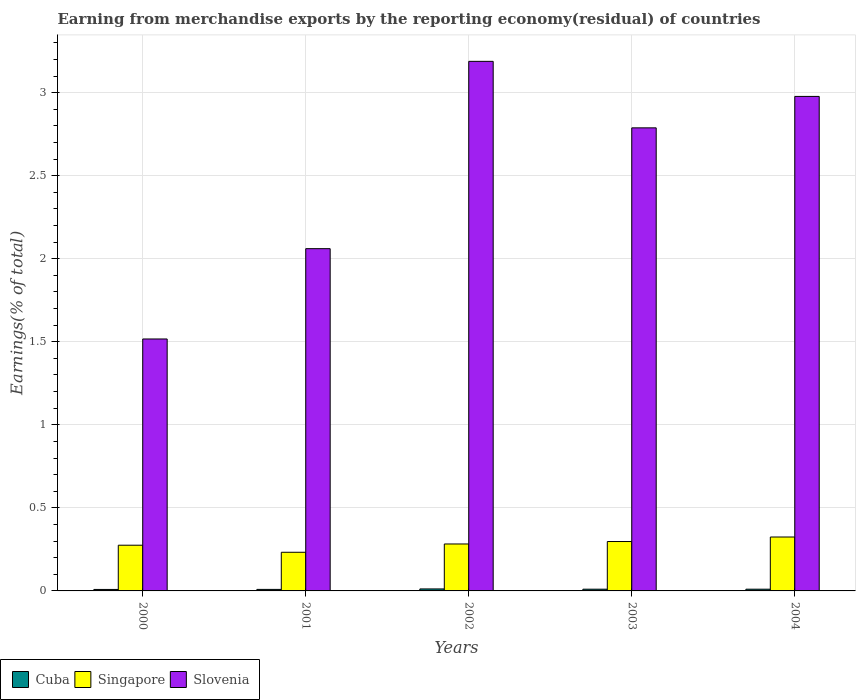How many different coloured bars are there?
Offer a very short reply. 3. How many groups of bars are there?
Give a very brief answer. 5. How many bars are there on the 5th tick from the left?
Your answer should be very brief. 3. What is the label of the 2nd group of bars from the left?
Provide a short and direct response. 2001. In how many cases, is the number of bars for a given year not equal to the number of legend labels?
Your answer should be compact. 0. What is the percentage of amount earned from merchandise exports in Singapore in 2004?
Give a very brief answer. 0.32. Across all years, what is the maximum percentage of amount earned from merchandise exports in Singapore?
Your answer should be very brief. 0.32. Across all years, what is the minimum percentage of amount earned from merchandise exports in Cuba?
Offer a very short reply. 0.01. In which year was the percentage of amount earned from merchandise exports in Cuba maximum?
Give a very brief answer. 2002. In which year was the percentage of amount earned from merchandise exports in Slovenia minimum?
Make the answer very short. 2000. What is the total percentage of amount earned from merchandise exports in Slovenia in the graph?
Ensure brevity in your answer.  12.53. What is the difference between the percentage of amount earned from merchandise exports in Singapore in 2002 and that in 2003?
Your response must be concise. -0.01. What is the difference between the percentage of amount earned from merchandise exports in Cuba in 2003 and the percentage of amount earned from merchandise exports in Singapore in 2002?
Your answer should be compact. -0.27. What is the average percentage of amount earned from merchandise exports in Singapore per year?
Provide a short and direct response. 0.28. In the year 2003, what is the difference between the percentage of amount earned from merchandise exports in Slovenia and percentage of amount earned from merchandise exports in Cuba?
Your answer should be compact. 2.78. In how many years, is the percentage of amount earned from merchandise exports in Slovenia greater than 3.2 %?
Your answer should be very brief. 0. What is the ratio of the percentage of amount earned from merchandise exports in Cuba in 2002 to that in 2004?
Your response must be concise. 1.16. Is the percentage of amount earned from merchandise exports in Cuba in 2001 less than that in 2002?
Provide a succinct answer. Yes. What is the difference between the highest and the second highest percentage of amount earned from merchandise exports in Singapore?
Your answer should be very brief. 0.03. What is the difference between the highest and the lowest percentage of amount earned from merchandise exports in Singapore?
Make the answer very short. 0.09. In how many years, is the percentage of amount earned from merchandise exports in Slovenia greater than the average percentage of amount earned from merchandise exports in Slovenia taken over all years?
Offer a terse response. 3. Is the sum of the percentage of amount earned from merchandise exports in Slovenia in 2002 and 2003 greater than the maximum percentage of amount earned from merchandise exports in Cuba across all years?
Ensure brevity in your answer.  Yes. What does the 1st bar from the left in 2004 represents?
Offer a terse response. Cuba. What does the 3rd bar from the right in 2002 represents?
Offer a very short reply. Cuba. How many bars are there?
Offer a terse response. 15. Are all the bars in the graph horizontal?
Offer a very short reply. No. How many years are there in the graph?
Offer a terse response. 5. Are the values on the major ticks of Y-axis written in scientific E-notation?
Give a very brief answer. No. Does the graph contain any zero values?
Offer a terse response. No. How many legend labels are there?
Your response must be concise. 3. How are the legend labels stacked?
Your answer should be very brief. Horizontal. What is the title of the graph?
Your response must be concise. Earning from merchandise exports by the reporting economy(residual) of countries. Does "Belize" appear as one of the legend labels in the graph?
Provide a short and direct response. No. What is the label or title of the Y-axis?
Offer a terse response. Earnings(% of total). What is the Earnings(% of total) in Cuba in 2000?
Keep it short and to the point. 0.01. What is the Earnings(% of total) in Singapore in 2000?
Provide a succinct answer. 0.28. What is the Earnings(% of total) in Slovenia in 2000?
Offer a terse response. 1.52. What is the Earnings(% of total) in Cuba in 2001?
Give a very brief answer. 0.01. What is the Earnings(% of total) in Singapore in 2001?
Your response must be concise. 0.23. What is the Earnings(% of total) in Slovenia in 2001?
Offer a terse response. 2.06. What is the Earnings(% of total) in Cuba in 2002?
Your response must be concise. 0.01. What is the Earnings(% of total) of Singapore in 2002?
Offer a terse response. 0.28. What is the Earnings(% of total) of Slovenia in 2002?
Your answer should be very brief. 3.19. What is the Earnings(% of total) of Cuba in 2003?
Provide a succinct answer. 0.01. What is the Earnings(% of total) in Singapore in 2003?
Ensure brevity in your answer.  0.3. What is the Earnings(% of total) in Slovenia in 2003?
Your response must be concise. 2.79. What is the Earnings(% of total) in Cuba in 2004?
Your answer should be very brief. 0.01. What is the Earnings(% of total) of Singapore in 2004?
Give a very brief answer. 0.32. What is the Earnings(% of total) in Slovenia in 2004?
Ensure brevity in your answer.  2.98. Across all years, what is the maximum Earnings(% of total) of Cuba?
Give a very brief answer. 0.01. Across all years, what is the maximum Earnings(% of total) in Singapore?
Give a very brief answer. 0.32. Across all years, what is the maximum Earnings(% of total) in Slovenia?
Make the answer very short. 3.19. Across all years, what is the minimum Earnings(% of total) in Cuba?
Make the answer very short. 0.01. Across all years, what is the minimum Earnings(% of total) in Singapore?
Provide a short and direct response. 0.23. Across all years, what is the minimum Earnings(% of total) in Slovenia?
Give a very brief answer. 1.52. What is the total Earnings(% of total) of Cuba in the graph?
Your answer should be very brief. 0.05. What is the total Earnings(% of total) of Singapore in the graph?
Offer a very short reply. 1.41. What is the total Earnings(% of total) of Slovenia in the graph?
Your answer should be very brief. 12.53. What is the difference between the Earnings(% of total) in Cuba in 2000 and that in 2001?
Provide a short and direct response. -0. What is the difference between the Earnings(% of total) of Singapore in 2000 and that in 2001?
Keep it short and to the point. 0.04. What is the difference between the Earnings(% of total) of Slovenia in 2000 and that in 2001?
Make the answer very short. -0.54. What is the difference between the Earnings(% of total) in Cuba in 2000 and that in 2002?
Your answer should be compact. -0. What is the difference between the Earnings(% of total) of Singapore in 2000 and that in 2002?
Provide a short and direct response. -0.01. What is the difference between the Earnings(% of total) in Slovenia in 2000 and that in 2002?
Your answer should be compact. -1.67. What is the difference between the Earnings(% of total) in Cuba in 2000 and that in 2003?
Ensure brevity in your answer.  -0. What is the difference between the Earnings(% of total) of Singapore in 2000 and that in 2003?
Offer a terse response. -0.02. What is the difference between the Earnings(% of total) in Slovenia in 2000 and that in 2003?
Your answer should be very brief. -1.27. What is the difference between the Earnings(% of total) of Cuba in 2000 and that in 2004?
Give a very brief answer. -0. What is the difference between the Earnings(% of total) of Singapore in 2000 and that in 2004?
Your answer should be compact. -0.05. What is the difference between the Earnings(% of total) in Slovenia in 2000 and that in 2004?
Your response must be concise. -1.46. What is the difference between the Earnings(% of total) in Cuba in 2001 and that in 2002?
Give a very brief answer. -0. What is the difference between the Earnings(% of total) in Slovenia in 2001 and that in 2002?
Offer a very short reply. -1.13. What is the difference between the Earnings(% of total) of Cuba in 2001 and that in 2003?
Offer a terse response. -0. What is the difference between the Earnings(% of total) of Singapore in 2001 and that in 2003?
Keep it short and to the point. -0.06. What is the difference between the Earnings(% of total) in Slovenia in 2001 and that in 2003?
Make the answer very short. -0.73. What is the difference between the Earnings(% of total) in Cuba in 2001 and that in 2004?
Give a very brief answer. -0. What is the difference between the Earnings(% of total) in Singapore in 2001 and that in 2004?
Offer a very short reply. -0.09. What is the difference between the Earnings(% of total) of Slovenia in 2001 and that in 2004?
Make the answer very short. -0.92. What is the difference between the Earnings(% of total) in Cuba in 2002 and that in 2003?
Your answer should be very brief. 0. What is the difference between the Earnings(% of total) in Singapore in 2002 and that in 2003?
Ensure brevity in your answer.  -0.01. What is the difference between the Earnings(% of total) in Slovenia in 2002 and that in 2003?
Provide a short and direct response. 0.4. What is the difference between the Earnings(% of total) in Cuba in 2002 and that in 2004?
Provide a succinct answer. 0. What is the difference between the Earnings(% of total) of Singapore in 2002 and that in 2004?
Make the answer very short. -0.04. What is the difference between the Earnings(% of total) in Slovenia in 2002 and that in 2004?
Your response must be concise. 0.21. What is the difference between the Earnings(% of total) of Singapore in 2003 and that in 2004?
Make the answer very short. -0.03. What is the difference between the Earnings(% of total) in Slovenia in 2003 and that in 2004?
Your answer should be compact. -0.19. What is the difference between the Earnings(% of total) in Cuba in 2000 and the Earnings(% of total) in Singapore in 2001?
Provide a short and direct response. -0.22. What is the difference between the Earnings(% of total) of Cuba in 2000 and the Earnings(% of total) of Slovenia in 2001?
Ensure brevity in your answer.  -2.05. What is the difference between the Earnings(% of total) of Singapore in 2000 and the Earnings(% of total) of Slovenia in 2001?
Your answer should be very brief. -1.79. What is the difference between the Earnings(% of total) of Cuba in 2000 and the Earnings(% of total) of Singapore in 2002?
Your answer should be very brief. -0.27. What is the difference between the Earnings(% of total) in Cuba in 2000 and the Earnings(% of total) in Slovenia in 2002?
Your answer should be very brief. -3.18. What is the difference between the Earnings(% of total) in Singapore in 2000 and the Earnings(% of total) in Slovenia in 2002?
Ensure brevity in your answer.  -2.91. What is the difference between the Earnings(% of total) in Cuba in 2000 and the Earnings(% of total) in Singapore in 2003?
Provide a short and direct response. -0.29. What is the difference between the Earnings(% of total) of Cuba in 2000 and the Earnings(% of total) of Slovenia in 2003?
Your answer should be compact. -2.78. What is the difference between the Earnings(% of total) in Singapore in 2000 and the Earnings(% of total) in Slovenia in 2003?
Your response must be concise. -2.51. What is the difference between the Earnings(% of total) in Cuba in 2000 and the Earnings(% of total) in Singapore in 2004?
Your response must be concise. -0.32. What is the difference between the Earnings(% of total) in Cuba in 2000 and the Earnings(% of total) in Slovenia in 2004?
Your response must be concise. -2.97. What is the difference between the Earnings(% of total) of Singapore in 2000 and the Earnings(% of total) of Slovenia in 2004?
Keep it short and to the point. -2.7. What is the difference between the Earnings(% of total) of Cuba in 2001 and the Earnings(% of total) of Singapore in 2002?
Offer a terse response. -0.27. What is the difference between the Earnings(% of total) in Cuba in 2001 and the Earnings(% of total) in Slovenia in 2002?
Provide a short and direct response. -3.18. What is the difference between the Earnings(% of total) in Singapore in 2001 and the Earnings(% of total) in Slovenia in 2002?
Your response must be concise. -2.96. What is the difference between the Earnings(% of total) in Cuba in 2001 and the Earnings(% of total) in Singapore in 2003?
Keep it short and to the point. -0.29. What is the difference between the Earnings(% of total) of Cuba in 2001 and the Earnings(% of total) of Slovenia in 2003?
Give a very brief answer. -2.78. What is the difference between the Earnings(% of total) in Singapore in 2001 and the Earnings(% of total) in Slovenia in 2003?
Offer a terse response. -2.56. What is the difference between the Earnings(% of total) of Cuba in 2001 and the Earnings(% of total) of Singapore in 2004?
Offer a very short reply. -0.32. What is the difference between the Earnings(% of total) in Cuba in 2001 and the Earnings(% of total) in Slovenia in 2004?
Keep it short and to the point. -2.97. What is the difference between the Earnings(% of total) in Singapore in 2001 and the Earnings(% of total) in Slovenia in 2004?
Ensure brevity in your answer.  -2.74. What is the difference between the Earnings(% of total) in Cuba in 2002 and the Earnings(% of total) in Singapore in 2003?
Keep it short and to the point. -0.29. What is the difference between the Earnings(% of total) in Cuba in 2002 and the Earnings(% of total) in Slovenia in 2003?
Offer a terse response. -2.78. What is the difference between the Earnings(% of total) of Singapore in 2002 and the Earnings(% of total) of Slovenia in 2003?
Provide a short and direct response. -2.51. What is the difference between the Earnings(% of total) of Cuba in 2002 and the Earnings(% of total) of Singapore in 2004?
Your response must be concise. -0.31. What is the difference between the Earnings(% of total) of Cuba in 2002 and the Earnings(% of total) of Slovenia in 2004?
Offer a very short reply. -2.97. What is the difference between the Earnings(% of total) of Singapore in 2002 and the Earnings(% of total) of Slovenia in 2004?
Your response must be concise. -2.69. What is the difference between the Earnings(% of total) in Cuba in 2003 and the Earnings(% of total) in Singapore in 2004?
Your answer should be very brief. -0.31. What is the difference between the Earnings(% of total) of Cuba in 2003 and the Earnings(% of total) of Slovenia in 2004?
Your answer should be very brief. -2.97. What is the difference between the Earnings(% of total) in Singapore in 2003 and the Earnings(% of total) in Slovenia in 2004?
Offer a very short reply. -2.68. What is the average Earnings(% of total) in Cuba per year?
Give a very brief answer. 0.01. What is the average Earnings(% of total) in Singapore per year?
Keep it short and to the point. 0.28. What is the average Earnings(% of total) in Slovenia per year?
Give a very brief answer. 2.51. In the year 2000, what is the difference between the Earnings(% of total) of Cuba and Earnings(% of total) of Singapore?
Ensure brevity in your answer.  -0.27. In the year 2000, what is the difference between the Earnings(% of total) of Cuba and Earnings(% of total) of Slovenia?
Your answer should be compact. -1.51. In the year 2000, what is the difference between the Earnings(% of total) in Singapore and Earnings(% of total) in Slovenia?
Keep it short and to the point. -1.24. In the year 2001, what is the difference between the Earnings(% of total) of Cuba and Earnings(% of total) of Singapore?
Your answer should be very brief. -0.22. In the year 2001, what is the difference between the Earnings(% of total) in Cuba and Earnings(% of total) in Slovenia?
Your response must be concise. -2.05. In the year 2001, what is the difference between the Earnings(% of total) of Singapore and Earnings(% of total) of Slovenia?
Ensure brevity in your answer.  -1.83. In the year 2002, what is the difference between the Earnings(% of total) of Cuba and Earnings(% of total) of Singapore?
Provide a short and direct response. -0.27. In the year 2002, what is the difference between the Earnings(% of total) in Cuba and Earnings(% of total) in Slovenia?
Provide a short and direct response. -3.18. In the year 2002, what is the difference between the Earnings(% of total) in Singapore and Earnings(% of total) in Slovenia?
Ensure brevity in your answer.  -2.91. In the year 2003, what is the difference between the Earnings(% of total) of Cuba and Earnings(% of total) of Singapore?
Your response must be concise. -0.29. In the year 2003, what is the difference between the Earnings(% of total) of Cuba and Earnings(% of total) of Slovenia?
Ensure brevity in your answer.  -2.78. In the year 2003, what is the difference between the Earnings(% of total) of Singapore and Earnings(% of total) of Slovenia?
Make the answer very short. -2.49. In the year 2004, what is the difference between the Earnings(% of total) in Cuba and Earnings(% of total) in Singapore?
Provide a succinct answer. -0.31. In the year 2004, what is the difference between the Earnings(% of total) of Cuba and Earnings(% of total) of Slovenia?
Your answer should be very brief. -2.97. In the year 2004, what is the difference between the Earnings(% of total) in Singapore and Earnings(% of total) in Slovenia?
Your answer should be compact. -2.65. What is the ratio of the Earnings(% of total) of Cuba in 2000 to that in 2001?
Provide a short and direct response. 0.97. What is the ratio of the Earnings(% of total) of Singapore in 2000 to that in 2001?
Ensure brevity in your answer.  1.18. What is the ratio of the Earnings(% of total) of Slovenia in 2000 to that in 2001?
Your answer should be compact. 0.74. What is the ratio of the Earnings(% of total) in Cuba in 2000 to that in 2002?
Give a very brief answer. 0.74. What is the ratio of the Earnings(% of total) in Singapore in 2000 to that in 2002?
Give a very brief answer. 0.97. What is the ratio of the Earnings(% of total) of Slovenia in 2000 to that in 2002?
Make the answer very short. 0.48. What is the ratio of the Earnings(% of total) in Cuba in 2000 to that in 2003?
Give a very brief answer. 0.85. What is the ratio of the Earnings(% of total) of Singapore in 2000 to that in 2003?
Your answer should be compact. 0.93. What is the ratio of the Earnings(% of total) of Slovenia in 2000 to that in 2003?
Keep it short and to the point. 0.54. What is the ratio of the Earnings(% of total) in Cuba in 2000 to that in 2004?
Offer a very short reply. 0.86. What is the ratio of the Earnings(% of total) in Singapore in 2000 to that in 2004?
Provide a short and direct response. 0.85. What is the ratio of the Earnings(% of total) of Slovenia in 2000 to that in 2004?
Provide a short and direct response. 0.51. What is the ratio of the Earnings(% of total) in Cuba in 2001 to that in 2002?
Provide a succinct answer. 0.77. What is the ratio of the Earnings(% of total) of Singapore in 2001 to that in 2002?
Keep it short and to the point. 0.82. What is the ratio of the Earnings(% of total) in Slovenia in 2001 to that in 2002?
Keep it short and to the point. 0.65. What is the ratio of the Earnings(% of total) in Cuba in 2001 to that in 2003?
Ensure brevity in your answer.  0.88. What is the ratio of the Earnings(% of total) in Singapore in 2001 to that in 2003?
Your answer should be compact. 0.78. What is the ratio of the Earnings(% of total) in Slovenia in 2001 to that in 2003?
Your answer should be very brief. 0.74. What is the ratio of the Earnings(% of total) of Cuba in 2001 to that in 2004?
Your answer should be compact. 0.89. What is the ratio of the Earnings(% of total) of Singapore in 2001 to that in 2004?
Your response must be concise. 0.72. What is the ratio of the Earnings(% of total) of Slovenia in 2001 to that in 2004?
Your answer should be compact. 0.69. What is the ratio of the Earnings(% of total) of Cuba in 2002 to that in 2003?
Offer a very short reply. 1.15. What is the ratio of the Earnings(% of total) in Singapore in 2002 to that in 2003?
Make the answer very short. 0.95. What is the ratio of the Earnings(% of total) in Slovenia in 2002 to that in 2003?
Provide a short and direct response. 1.14. What is the ratio of the Earnings(% of total) in Cuba in 2002 to that in 2004?
Keep it short and to the point. 1.16. What is the ratio of the Earnings(% of total) in Singapore in 2002 to that in 2004?
Give a very brief answer. 0.87. What is the ratio of the Earnings(% of total) of Slovenia in 2002 to that in 2004?
Your answer should be very brief. 1.07. What is the ratio of the Earnings(% of total) of Cuba in 2003 to that in 2004?
Provide a succinct answer. 1.01. What is the ratio of the Earnings(% of total) in Singapore in 2003 to that in 2004?
Ensure brevity in your answer.  0.92. What is the ratio of the Earnings(% of total) in Slovenia in 2003 to that in 2004?
Provide a short and direct response. 0.94. What is the difference between the highest and the second highest Earnings(% of total) of Cuba?
Offer a very short reply. 0. What is the difference between the highest and the second highest Earnings(% of total) of Singapore?
Ensure brevity in your answer.  0.03. What is the difference between the highest and the second highest Earnings(% of total) in Slovenia?
Provide a succinct answer. 0.21. What is the difference between the highest and the lowest Earnings(% of total) of Cuba?
Ensure brevity in your answer.  0. What is the difference between the highest and the lowest Earnings(% of total) of Singapore?
Your answer should be compact. 0.09. What is the difference between the highest and the lowest Earnings(% of total) of Slovenia?
Keep it short and to the point. 1.67. 